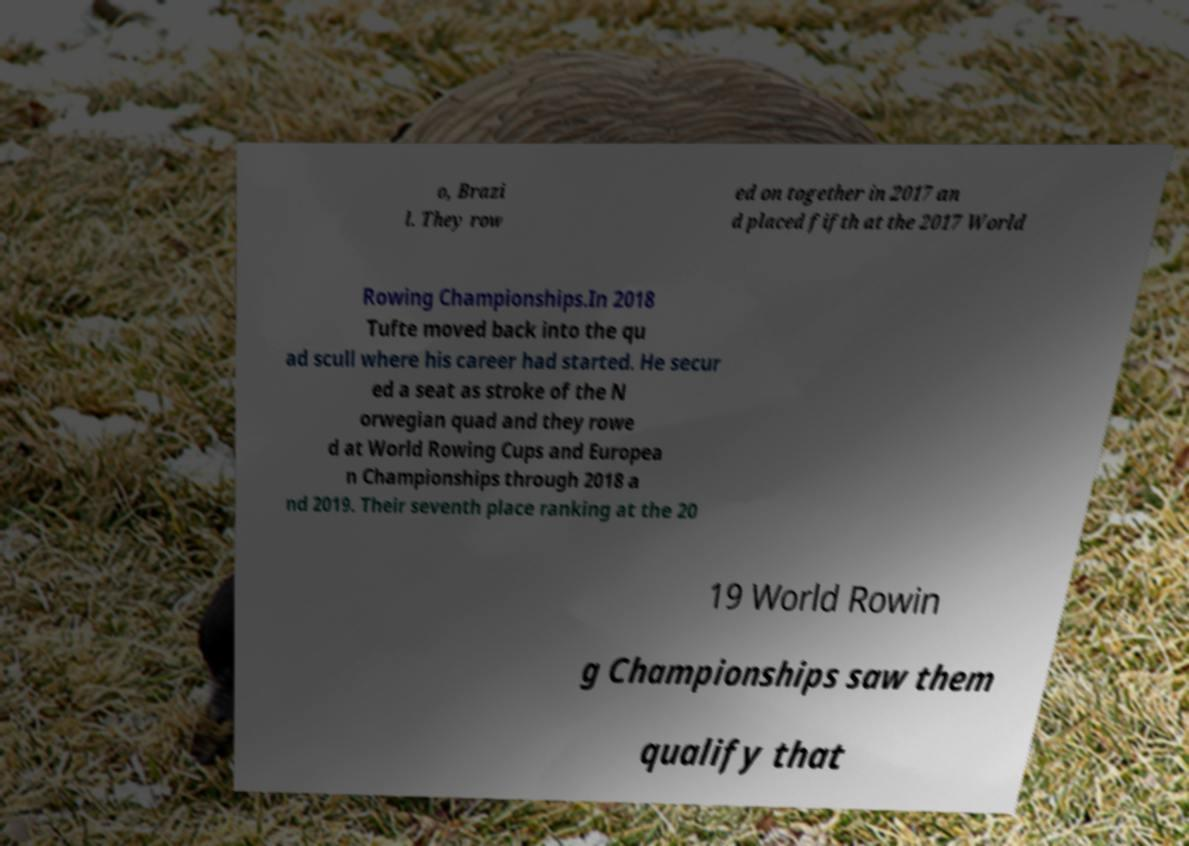Could you assist in decoding the text presented in this image and type it out clearly? o, Brazi l. They row ed on together in 2017 an d placed fifth at the 2017 World Rowing Championships.In 2018 Tufte moved back into the qu ad scull where his career had started. He secur ed a seat as stroke of the N orwegian quad and they rowe d at World Rowing Cups and Europea n Championships through 2018 a nd 2019. Their seventh place ranking at the 20 19 World Rowin g Championships saw them qualify that 